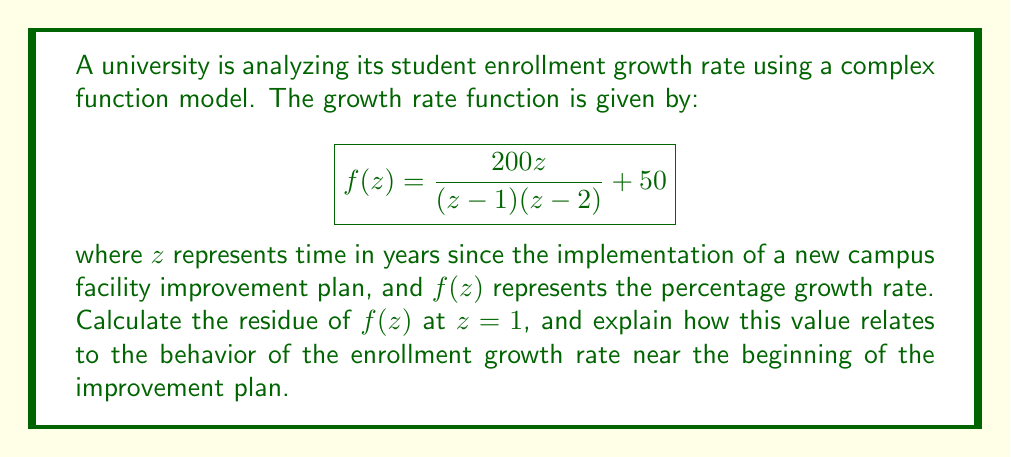Can you solve this math problem? To solve this problem, we'll follow these steps:

1) First, we need to understand what the residue represents in this context. The residue at a pole gives us information about the behavior of the function near that point.

2) The function $f(z)$ has two simple poles: at $z=1$ and $z=2$. We're asked to find the residue at $z=1$.

3) For a simple pole, the residue can be calculated using the formula:

   $$\text{Res}(f,a) = \lim_{z \to a} (z-a)f(z)$$

4) In our case, $a=1$, so we need to calculate:

   $$\text{Res}(f,1) = \lim_{z \to 1} (z-1)f(z)$$

5) Let's substitute the function:

   $$\text{Res}(f,1) = \lim_{z \to 1} (z-1)\left(\frac{200z}{(z-1)(z-2)} + 50\right)$$

6) Simplify:

   $$\text{Res}(f,1) = \lim_{z \to 1} \left(\frac{200z}{z-2} + 50(z-1)\right)$$

7) As $z \to 1$, the second term goes to zero, so we have:

   $$\text{Res}(f,1) = \lim_{z \to 1} \frac{200z}{z-2} = \frac{200}{-1} = -200$$

8) Interpretation: The residue of -200 at $z=1$ indicates a significant spike in the enrollment growth rate near the beginning of the improvement plan. This suggests that the new facilities had an immediate and substantial positive impact on student enrollment.
Answer: The residue of $f(z)$ at $z=1$ is $-200$. This indicates a sharp increase in enrollment growth rate at the beginning of the campus facility improvement plan. 